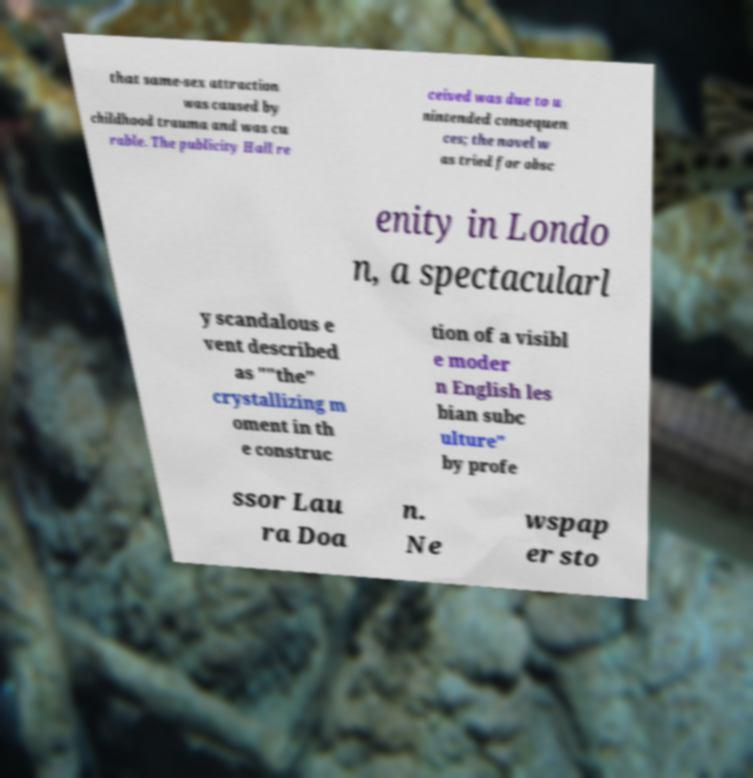What messages or text are displayed in this image? I need them in a readable, typed format. that same-sex attraction was caused by childhood trauma and was cu rable. The publicity Hall re ceived was due to u nintended consequen ces; the novel w as tried for obsc enity in Londo n, a spectacularl y scandalous e vent described as ""the" crystallizing m oment in th e construc tion of a visibl e moder n English les bian subc ulture" by profe ssor Lau ra Doa n. Ne wspap er sto 